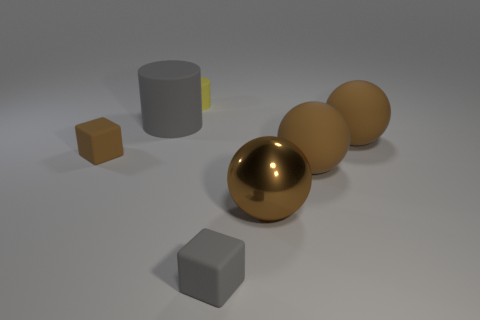How many things are either yellow objects or big gray cylinders?
Ensure brevity in your answer.  2. There is a cylinder behind the large thing that is on the left side of the yellow cylinder; how many tiny rubber objects are right of it?
Offer a very short reply. 1. Is there any other thing of the same color as the metallic ball?
Provide a short and direct response. Yes. Do the small matte cube that is to the right of the yellow matte cylinder and the large matte object left of the brown shiny object have the same color?
Give a very brief answer. Yes. Is the number of small rubber cubes right of the yellow matte cylinder greater than the number of gray matte objects left of the large cylinder?
Provide a short and direct response. Yes. What is the shape of the tiny matte thing behind the tiny rubber block behind the small gray rubber thing that is right of the small cylinder?
Offer a very short reply. Cylinder. What number of other objects are the same material as the tiny brown object?
Offer a terse response. 5. Are the small thing that is in front of the tiny brown object and the brown thing that is to the left of the large matte cylinder made of the same material?
Give a very brief answer. Yes. How many objects are in front of the large gray object and on the right side of the small brown rubber thing?
Give a very brief answer. 4. Are there any tiny gray things that have the same shape as the tiny brown thing?
Offer a terse response. Yes. 